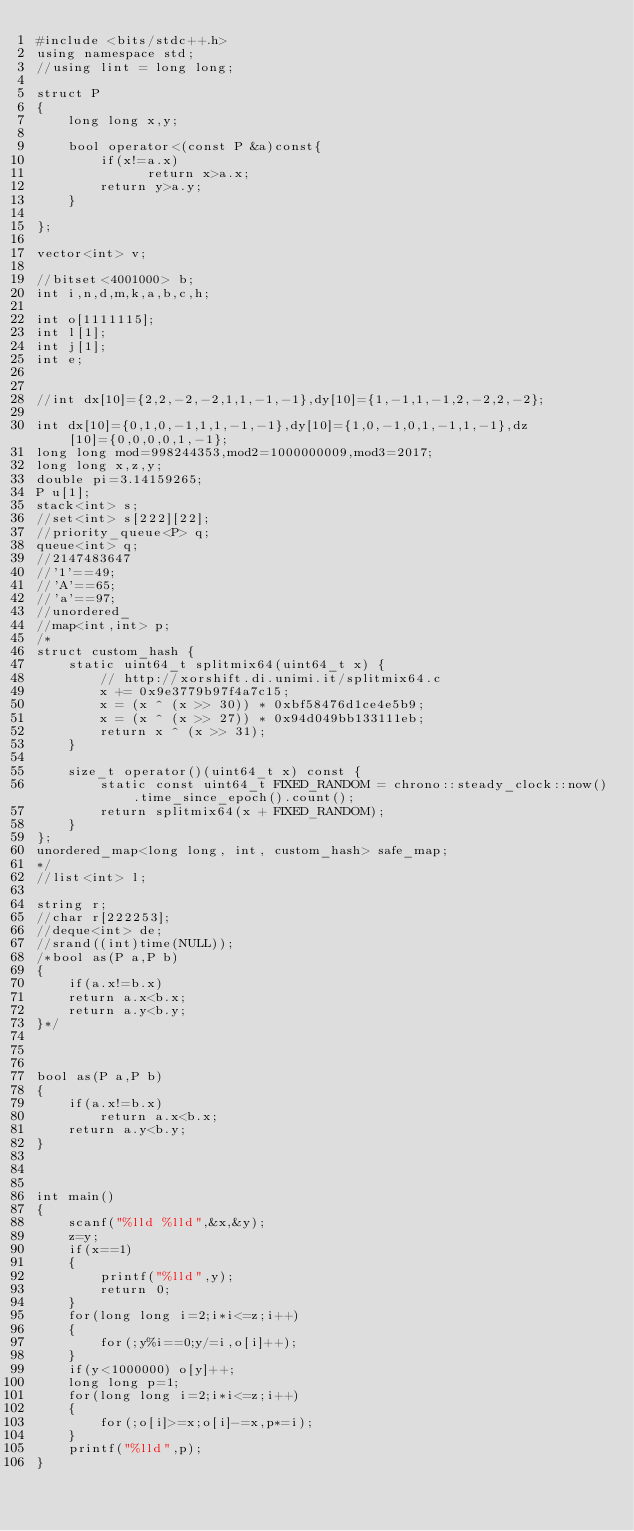<code> <loc_0><loc_0><loc_500><loc_500><_C++_>#include <bits/stdc++.h>
using namespace std;
//using lint = long long;

struct P
{
    long long x,y;

    bool operator<(const P &a)const{
        if(x!=a.x)
              return x>a.x;
        return y>a.y;
    }

};

vector<int> v;

//bitset<4001000> b;
int i,n,d,m,k,a,b,c,h;

int o[1111115];
int l[1];
int j[1];
int e;


//int dx[10]={2,2,-2,-2,1,1,-1,-1},dy[10]={1,-1,1,-1,2,-2,2,-2};

int dx[10]={0,1,0,-1,1,1,-1,-1},dy[10]={1,0,-1,0,1,-1,1,-1},dz[10]={0,0,0,0,1,-1};
long long mod=998244353,mod2=1000000009,mod3=2017;
long long x,z,y;
double pi=3.14159265;
P u[1];
stack<int> s;
//set<int> s[222][22];
//priority_queue<P> q;
queue<int> q;
//2147483647
//'1'==49;
//'A'==65;
//'a'==97;
//unordered_
//map<int,int> p;
/*
struct custom_hash {
    static uint64_t splitmix64(uint64_t x) {
        // http://xorshift.di.unimi.it/splitmix64.c
        x += 0x9e3779b97f4a7c15;
        x = (x ^ (x >> 30)) * 0xbf58476d1ce4e5b9;
        x = (x ^ (x >> 27)) * 0x94d049bb133111eb;
        return x ^ (x >> 31);
    }

    size_t operator()(uint64_t x) const {
        static const uint64_t FIXED_RANDOM = chrono::steady_clock::now().time_since_epoch().count();
        return splitmix64(x + FIXED_RANDOM);
    }
};
unordered_map<long long, int, custom_hash> safe_map;
*/
//list<int> l;

string r;
//char r[222253];
//deque<int> de;
//srand((int)time(NULL));
/*bool as(P a,P b)
{
    if(a.x!=b.x)
    return a.x<b.x;
    return a.y<b.y;
}*/



bool as(P a,P b)
{
    if(a.x!=b.x)
        return a.x<b.x;
    return a.y<b.y;
}



int main()
{
    scanf("%lld %lld",&x,&y);
    z=y;
    if(x==1)
    {
        printf("%lld",y);
        return 0;
    }
    for(long long i=2;i*i<=z;i++)
    {
        for(;y%i==0;y/=i,o[i]++);
    }
    if(y<1000000) o[y]++;
    long long p=1;
    for(long long i=2;i*i<=z;i++)
    {
        for(;o[i]>=x;o[i]-=x,p*=i);
    }
    printf("%lld",p);
}



</code> 